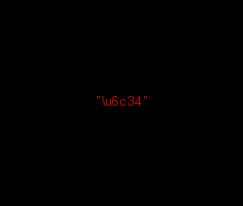Convert code to text. <code><loc_0><loc_0><loc_500><loc_500><_Lisp_>"\u6c34"
</code> 